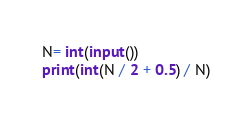Convert code to text. <code><loc_0><loc_0><loc_500><loc_500><_Python_>N= int(input())
print(int(N / 2 + 0.5) / N)
</code> 